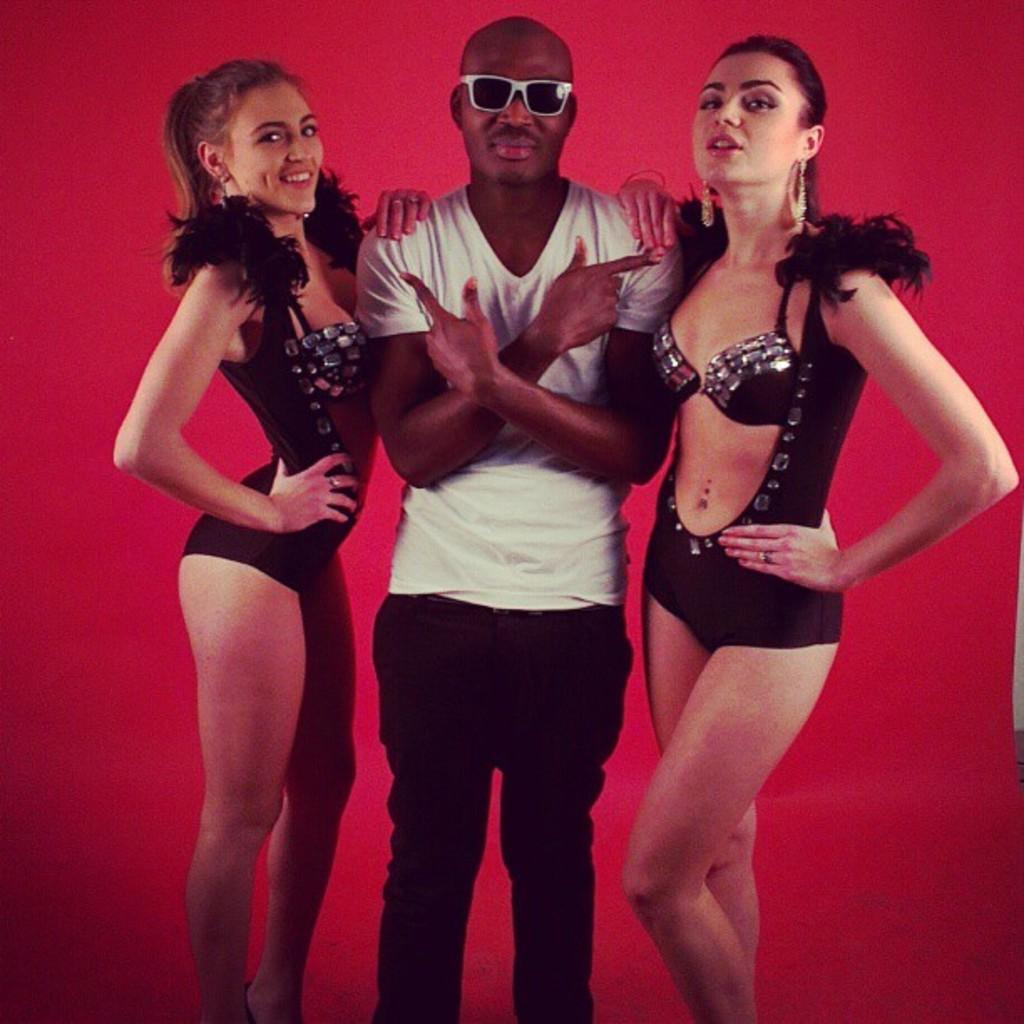What is the main subject in the center of the image? There is a man standing in the center of the image. What is the man wearing on his face? The man is wearing goggles. How many women are standing beside the man? There are two women standing beside the man. What color is the background of the image? The background of the image is red. What type of soup is being served in the image? There is no soup present in the image. What is the scarecrow wearing in the image? There is no scarecrow present in the image. 